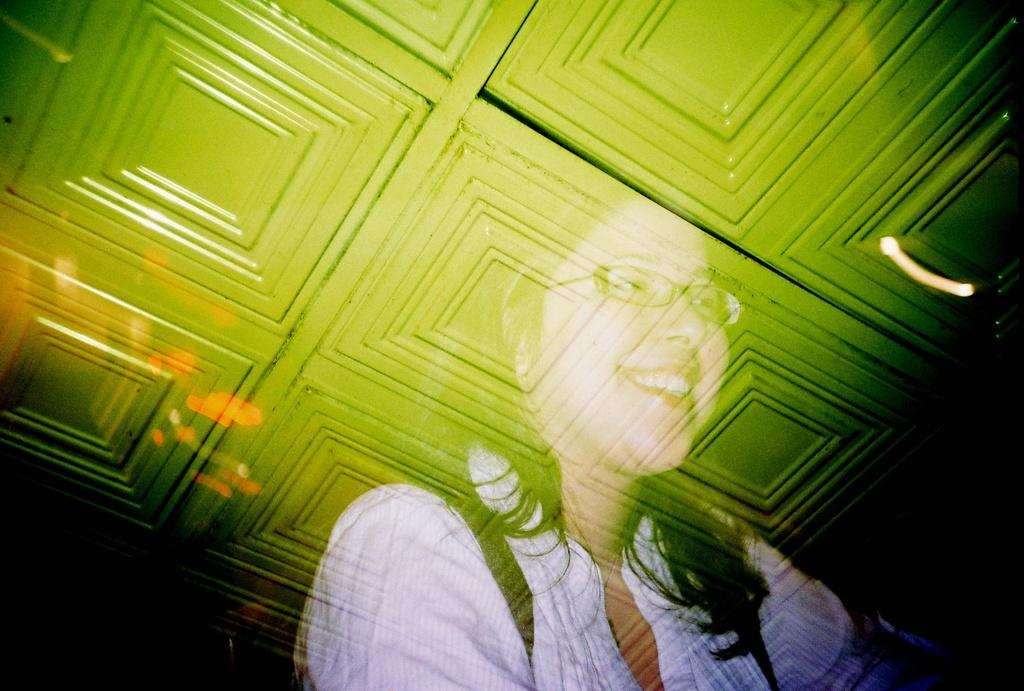What type of image is being described? The image is animated. Can you describe any characters or figures in the image? Yes, there is a woman in the image. What type of pets does the woman have in the image? There is no information about pets in the image; it only mentions the presence of a woman. How many feet does the woman have in the image? The woman in the image has two feet, as humans typically have two feet. However, this question is absurd because it assumes that the woman has an abnormal number of feet, which is not supported by the given facts. 